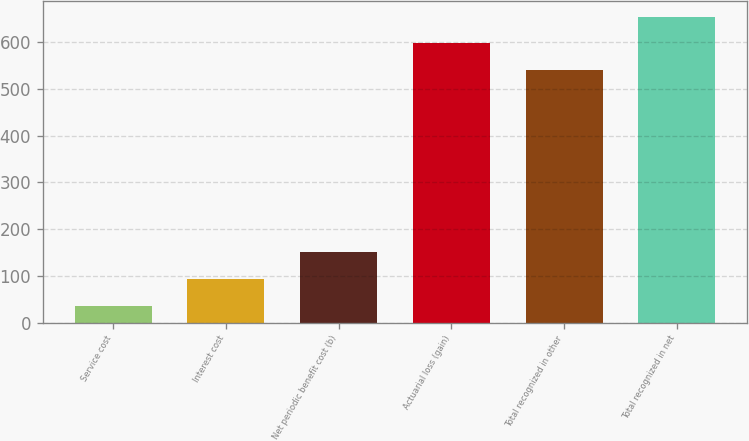Convert chart. <chart><loc_0><loc_0><loc_500><loc_500><bar_chart><fcel>Service cost<fcel>Interest cost<fcel>Net periodic benefit cost (b)<fcel>Actuarial loss (gain)<fcel>Total recognized in other<fcel>Total recognized in net<nl><fcel>36<fcel>93<fcel>150<fcel>598<fcel>541<fcel>655<nl></chart> 